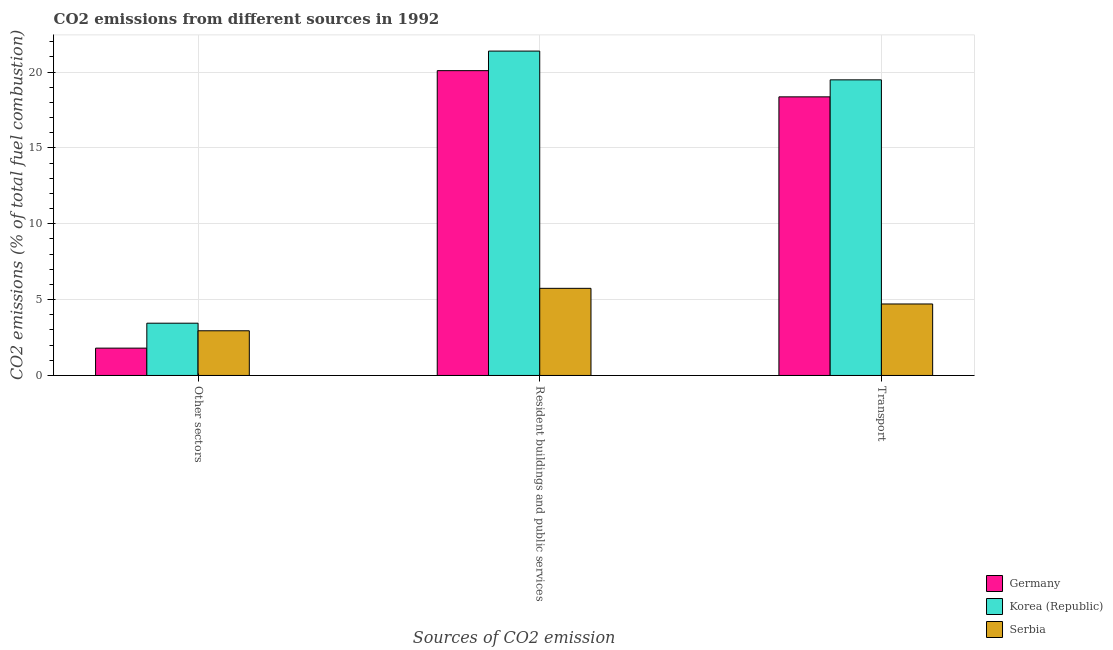How many groups of bars are there?
Give a very brief answer. 3. How many bars are there on the 2nd tick from the right?
Provide a succinct answer. 3. What is the label of the 1st group of bars from the left?
Provide a short and direct response. Other sectors. What is the percentage of co2 emissions from transport in Germany?
Provide a short and direct response. 18.36. Across all countries, what is the maximum percentage of co2 emissions from other sectors?
Provide a short and direct response. 3.45. Across all countries, what is the minimum percentage of co2 emissions from other sectors?
Offer a very short reply. 1.8. In which country was the percentage of co2 emissions from resident buildings and public services minimum?
Offer a terse response. Serbia. What is the total percentage of co2 emissions from transport in the graph?
Offer a terse response. 42.56. What is the difference between the percentage of co2 emissions from other sectors in Serbia and that in Germany?
Provide a short and direct response. 1.14. What is the difference between the percentage of co2 emissions from resident buildings and public services in Korea (Republic) and the percentage of co2 emissions from transport in Serbia?
Offer a very short reply. 16.67. What is the average percentage of co2 emissions from transport per country?
Your answer should be compact. 14.19. What is the difference between the percentage of co2 emissions from resident buildings and public services and percentage of co2 emissions from other sectors in Germany?
Offer a terse response. 18.29. In how many countries, is the percentage of co2 emissions from transport greater than 15 %?
Make the answer very short. 2. What is the ratio of the percentage of co2 emissions from other sectors in Korea (Republic) to that in Serbia?
Ensure brevity in your answer.  1.17. Is the percentage of co2 emissions from other sectors in Korea (Republic) less than that in Serbia?
Give a very brief answer. No. What is the difference between the highest and the second highest percentage of co2 emissions from transport?
Your answer should be very brief. 1.12. What is the difference between the highest and the lowest percentage of co2 emissions from other sectors?
Your answer should be compact. 1.64. Is the sum of the percentage of co2 emissions from resident buildings and public services in Germany and Serbia greater than the maximum percentage of co2 emissions from other sectors across all countries?
Ensure brevity in your answer.  Yes. What does the 1st bar from the left in Resident buildings and public services represents?
Offer a terse response. Germany. How many bars are there?
Give a very brief answer. 9. What is the difference between two consecutive major ticks on the Y-axis?
Ensure brevity in your answer.  5. Are the values on the major ticks of Y-axis written in scientific E-notation?
Make the answer very short. No. Does the graph contain any zero values?
Your response must be concise. No. Where does the legend appear in the graph?
Offer a very short reply. Bottom right. How many legend labels are there?
Give a very brief answer. 3. What is the title of the graph?
Make the answer very short. CO2 emissions from different sources in 1992. Does "Paraguay" appear as one of the legend labels in the graph?
Provide a succinct answer. No. What is the label or title of the X-axis?
Keep it short and to the point. Sources of CO2 emission. What is the label or title of the Y-axis?
Your answer should be compact. CO2 emissions (% of total fuel combustion). What is the CO2 emissions (% of total fuel combustion) of Germany in Other sectors?
Your response must be concise. 1.8. What is the CO2 emissions (% of total fuel combustion) in Korea (Republic) in Other sectors?
Make the answer very short. 3.45. What is the CO2 emissions (% of total fuel combustion) of Serbia in Other sectors?
Your answer should be very brief. 2.94. What is the CO2 emissions (% of total fuel combustion) in Germany in Resident buildings and public services?
Your response must be concise. 20.09. What is the CO2 emissions (% of total fuel combustion) in Korea (Republic) in Resident buildings and public services?
Offer a terse response. 21.38. What is the CO2 emissions (% of total fuel combustion) in Serbia in Resident buildings and public services?
Your answer should be very brief. 5.74. What is the CO2 emissions (% of total fuel combustion) in Germany in Transport?
Provide a short and direct response. 18.36. What is the CO2 emissions (% of total fuel combustion) in Korea (Republic) in Transport?
Provide a succinct answer. 19.48. What is the CO2 emissions (% of total fuel combustion) of Serbia in Transport?
Keep it short and to the point. 4.71. Across all Sources of CO2 emission, what is the maximum CO2 emissions (% of total fuel combustion) in Germany?
Offer a very short reply. 20.09. Across all Sources of CO2 emission, what is the maximum CO2 emissions (% of total fuel combustion) of Korea (Republic)?
Offer a terse response. 21.38. Across all Sources of CO2 emission, what is the maximum CO2 emissions (% of total fuel combustion) in Serbia?
Keep it short and to the point. 5.74. Across all Sources of CO2 emission, what is the minimum CO2 emissions (% of total fuel combustion) of Germany?
Your answer should be compact. 1.8. Across all Sources of CO2 emission, what is the minimum CO2 emissions (% of total fuel combustion) of Korea (Republic)?
Provide a succinct answer. 3.45. Across all Sources of CO2 emission, what is the minimum CO2 emissions (% of total fuel combustion) in Serbia?
Ensure brevity in your answer.  2.94. What is the total CO2 emissions (% of total fuel combustion) of Germany in the graph?
Provide a short and direct response. 40.25. What is the total CO2 emissions (% of total fuel combustion) in Korea (Republic) in the graph?
Keep it short and to the point. 44.31. What is the total CO2 emissions (% of total fuel combustion) of Serbia in the graph?
Your answer should be very brief. 13.4. What is the difference between the CO2 emissions (% of total fuel combustion) in Germany in Other sectors and that in Resident buildings and public services?
Offer a very short reply. -18.29. What is the difference between the CO2 emissions (% of total fuel combustion) in Korea (Republic) in Other sectors and that in Resident buildings and public services?
Make the answer very short. -17.93. What is the difference between the CO2 emissions (% of total fuel combustion) in Serbia in Other sectors and that in Resident buildings and public services?
Your answer should be very brief. -2.8. What is the difference between the CO2 emissions (% of total fuel combustion) of Germany in Other sectors and that in Transport?
Your response must be concise. -16.56. What is the difference between the CO2 emissions (% of total fuel combustion) of Korea (Republic) in Other sectors and that in Transport?
Your answer should be compact. -16.04. What is the difference between the CO2 emissions (% of total fuel combustion) in Serbia in Other sectors and that in Transport?
Your response must be concise. -1.77. What is the difference between the CO2 emissions (% of total fuel combustion) in Germany in Resident buildings and public services and that in Transport?
Your answer should be compact. 1.73. What is the difference between the CO2 emissions (% of total fuel combustion) of Korea (Republic) in Resident buildings and public services and that in Transport?
Your answer should be compact. 1.9. What is the difference between the CO2 emissions (% of total fuel combustion) in Serbia in Resident buildings and public services and that in Transport?
Keep it short and to the point. 1.03. What is the difference between the CO2 emissions (% of total fuel combustion) in Germany in Other sectors and the CO2 emissions (% of total fuel combustion) in Korea (Republic) in Resident buildings and public services?
Your response must be concise. -19.58. What is the difference between the CO2 emissions (% of total fuel combustion) in Germany in Other sectors and the CO2 emissions (% of total fuel combustion) in Serbia in Resident buildings and public services?
Ensure brevity in your answer.  -3.94. What is the difference between the CO2 emissions (% of total fuel combustion) in Korea (Republic) in Other sectors and the CO2 emissions (% of total fuel combustion) in Serbia in Resident buildings and public services?
Provide a succinct answer. -2.3. What is the difference between the CO2 emissions (% of total fuel combustion) in Germany in Other sectors and the CO2 emissions (% of total fuel combustion) in Korea (Republic) in Transport?
Your answer should be compact. -17.68. What is the difference between the CO2 emissions (% of total fuel combustion) of Germany in Other sectors and the CO2 emissions (% of total fuel combustion) of Serbia in Transport?
Your answer should be very brief. -2.91. What is the difference between the CO2 emissions (% of total fuel combustion) in Korea (Republic) in Other sectors and the CO2 emissions (% of total fuel combustion) in Serbia in Transport?
Offer a very short reply. -1.27. What is the difference between the CO2 emissions (% of total fuel combustion) of Germany in Resident buildings and public services and the CO2 emissions (% of total fuel combustion) of Korea (Republic) in Transport?
Give a very brief answer. 0.61. What is the difference between the CO2 emissions (% of total fuel combustion) in Germany in Resident buildings and public services and the CO2 emissions (% of total fuel combustion) in Serbia in Transport?
Provide a short and direct response. 15.38. What is the difference between the CO2 emissions (% of total fuel combustion) of Korea (Republic) in Resident buildings and public services and the CO2 emissions (% of total fuel combustion) of Serbia in Transport?
Make the answer very short. 16.67. What is the average CO2 emissions (% of total fuel combustion) in Germany per Sources of CO2 emission?
Ensure brevity in your answer.  13.42. What is the average CO2 emissions (% of total fuel combustion) in Korea (Republic) per Sources of CO2 emission?
Offer a very short reply. 14.77. What is the average CO2 emissions (% of total fuel combustion) in Serbia per Sources of CO2 emission?
Make the answer very short. 4.47. What is the difference between the CO2 emissions (% of total fuel combustion) in Germany and CO2 emissions (% of total fuel combustion) in Korea (Republic) in Other sectors?
Your answer should be very brief. -1.64. What is the difference between the CO2 emissions (% of total fuel combustion) in Germany and CO2 emissions (% of total fuel combustion) in Serbia in Other sectors?
Offer a very short reply. -1.14. What is the difference between the CO2 emissions (% of total fuel combustion) of Korea (Republic) and CO2 emissions (% of total fuel combustion) of Serbia in Other sectors?
Your answer should be very brief. 0.5. What is the difference between the CO2 emissions (% of total fuel combustion) of Germany and CO2 emissions (% of total fuel combustion) of Korea (Republic) in Resident buildings and public services?
Give a very brief answer. -1.29. What is the difference between the CO2 emissions (% of total fuel combustion) in Germany and CO2 emissions (% of total fuel combustion) in Serbia in Resident buildings and public services?
Offer a terse response. 14.35. What is the difference between the CO2 emissions (% of total fuel combustion) in Korea (Republic) and CO2 emissions (% of total fuel combustion) in Serbia in Resident buildings and public services?
Offer a terse response. 15.64. What is the difference between the CO2 emissions (% of total fuel combustion) in Germany and CO2 emissions (% of total fuel combustion) in Korea (Republic) in Transport?
Give a very brief answer. -1.12. What is the difference between the CO2 emissions (% of total fuel combustion) in Germany and CO2 emissions (% of total fuel combustion) in Serbia in Transport?
Your answer should be very brief. 13.65. What is the difference between the CO2 emissions (% of total fuel combustion) in Korea (Republic) and CO2 emissions (% of total fuel combustion) in Serbia in Transport?
Offer a very short reply. 14.77. What is the ratio of the CO2 emissions (% of total fuel combustion) in Germany in Other sectors to that in Resident buildings and public services?
Your answer should be compact. 0.09. What is the ratio of the CO2 emissions (% of total fuel combustion) of Korea (Republic) in Other sectors to that in Resident buildings and public services?
Your answer should be compact. 0.16. What is the ratio of the CO2 emissions (% of total fuel combustion) of Serbia in Other sectors to that in Resident buildings and public services?
Give a very brief answer. 0.51. What is the ratio of the CO2 emissions (% of total fuel combustion) in Germany in Other sectors to that in Transport?
Your answer should be very brief. 0.1. What is the ratio of the CO2 emissions (% of total fuel combustion) of Korea (Republic) in Other sectors to that in Transport?
Give a very brief answer. 0.18. What is the ratio of the CO2 emissions (% of total fuel combustion) in Germany in Resident buildings and public services to that in Transport?
Your answer should be very brief. 1.09. What is the ratio of the CO2 emissions (% of total fuel combustion) in Korea (Republic) in Resident buildings and public services to that in Transport?
Provide a short and direct response. 1.1. What is the ratio of the CO2 emissions (% of total fuel combustion) in Serbia in Resident buildings and public services to that in Transport?
Ensure brevity in your answer.  1.22. What is the difference between the highest and the second highest CO2 emissions (% of total fuel combustion) in Germany?
Offer a terse response. 1.73. What is the difference between the highest and the second highest CO2 emissions (% of total fuel combustion) in Korea (Republic)?
Your answer should be very brief. 1.9. What is the difference between the highest and the second highest CO2 emissions (% of total fuel combustion) in Serbia?
Offer a very short reply. 1.03. What is the difference between the highest and the lowest CO2 emissions (% of total fuel combustion) in Germany?
Your answer should be compact. 18.29. What is the difference between the highest and the lowest CO2 emissions (% of total fuel combustion) of Korea (Republic)?
Your answer should be compact. 17.93. What is the difference between the highest and the lowest CO2 emissions (% of total fuel combustion) of Serbia?
Keep it short and to the point. 2.8. 